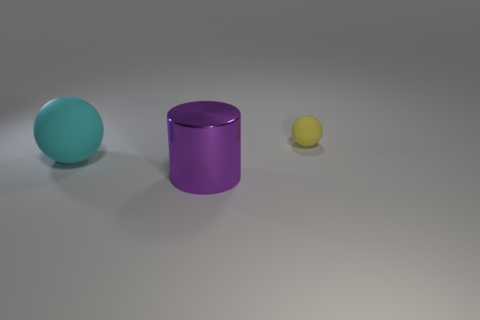There is a thing that is right of the large cyan matte object and in front of the tiny thing; what material is it made of?
Keep it short and to the point. Metal. Are there more objects that are behind the large purple metallic thing than small yellow matte balls?
Offer a terse response. Yes. Are there any spheres that are in front of the matte sphere behind the matte thing that is to the left of the small matte ball?
Your response must be concise. Yes. There is a metal thing; are there any tiny yellow objects behind it?
Ensure brevity in your answer.  Yes. There is a thing that is made of the same material as the tiny yellow ball; what size is it?
Your response must be concise. Large. What is the size of the purple cylinder on the right side of the rubber thing left of the rubber thing on the right side of the large cyan rubber object?
Provide a succinct answer. Large. How big is the thing in front of the cyan ball?
Your response must be concise. Large. How many blue objects are either small things or big shiny cylinders?
Offer a very short reply. 0. Are there any things that have the same size as the purple cylinder?
Offer a very short reply. Yes. What material is the sphere that is the same size as the purple thing?
Offer a very short reply. Rubber. 